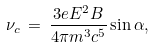<formula> <loc_0><loc_0><loc_500><loc_500>\nu _ { c } \, = \, \frac { 3 e E ^ { 2 } B } { 4 \pi m ^ { 3 } c ^ { 5 } } \sin { \alpha } ,</formula> 